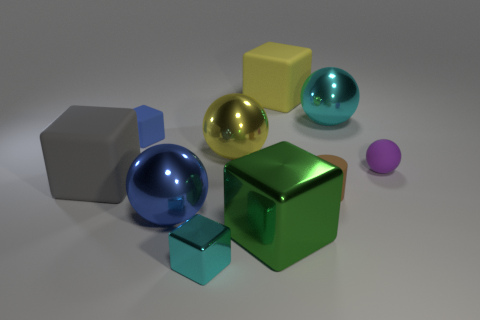Are there any things behind the rubber block in front of the purple thing?
Offer a very short reply. Yes. What number of objects are matte objects that are left of the tiny cyan metal thing or tiny rubber cylinders?
Give a very brief answer. 3. What is the material of the tiny object to the right of the cylinder that is in front of the large yellow sphere?
Your answer should be very brief. Rubber. Are there the same number of small matte things that are on the left side of the tiny cylinder and big metal objects that are to the right of the gray block?
Make the answer very short. No. What number of objects are large spheres left of the big cyan metal sphere or rubber cubes on the left side of the big green shiny thing?
Your response must be concise. 4. There is a cube that is both in front of the matte ball and behind the brown matte thing; what is its material?
Your answer should be very brief. Rubber. There is a blue object that is left of the ball that is in front of the large gray rubber block left of the blue cube; what is its size?
Make the answer very short. Small. Are there more large gray things than big gray shiny spheres?
Provide a succinct answer. Yes. Is the material of the large cube behind the small ball the same as the cyan sphere?
Ensure brevity in your answer.  No. Are there fewer large gray metallic balls than tiny matte balls?
Ensure brevity in your answer.  Yes. 